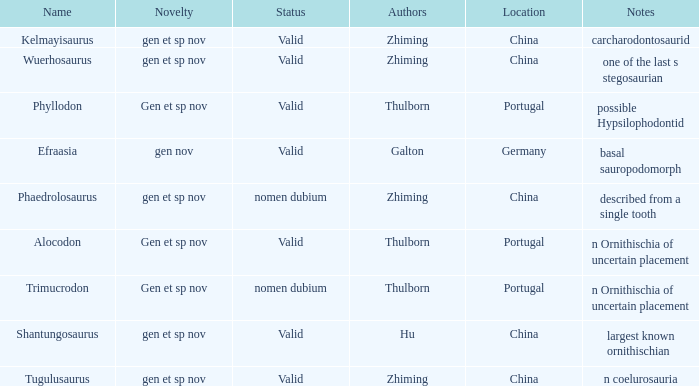What is the Status of the dinosaur, whose notes are, "n coelurosauria"? Valid. 